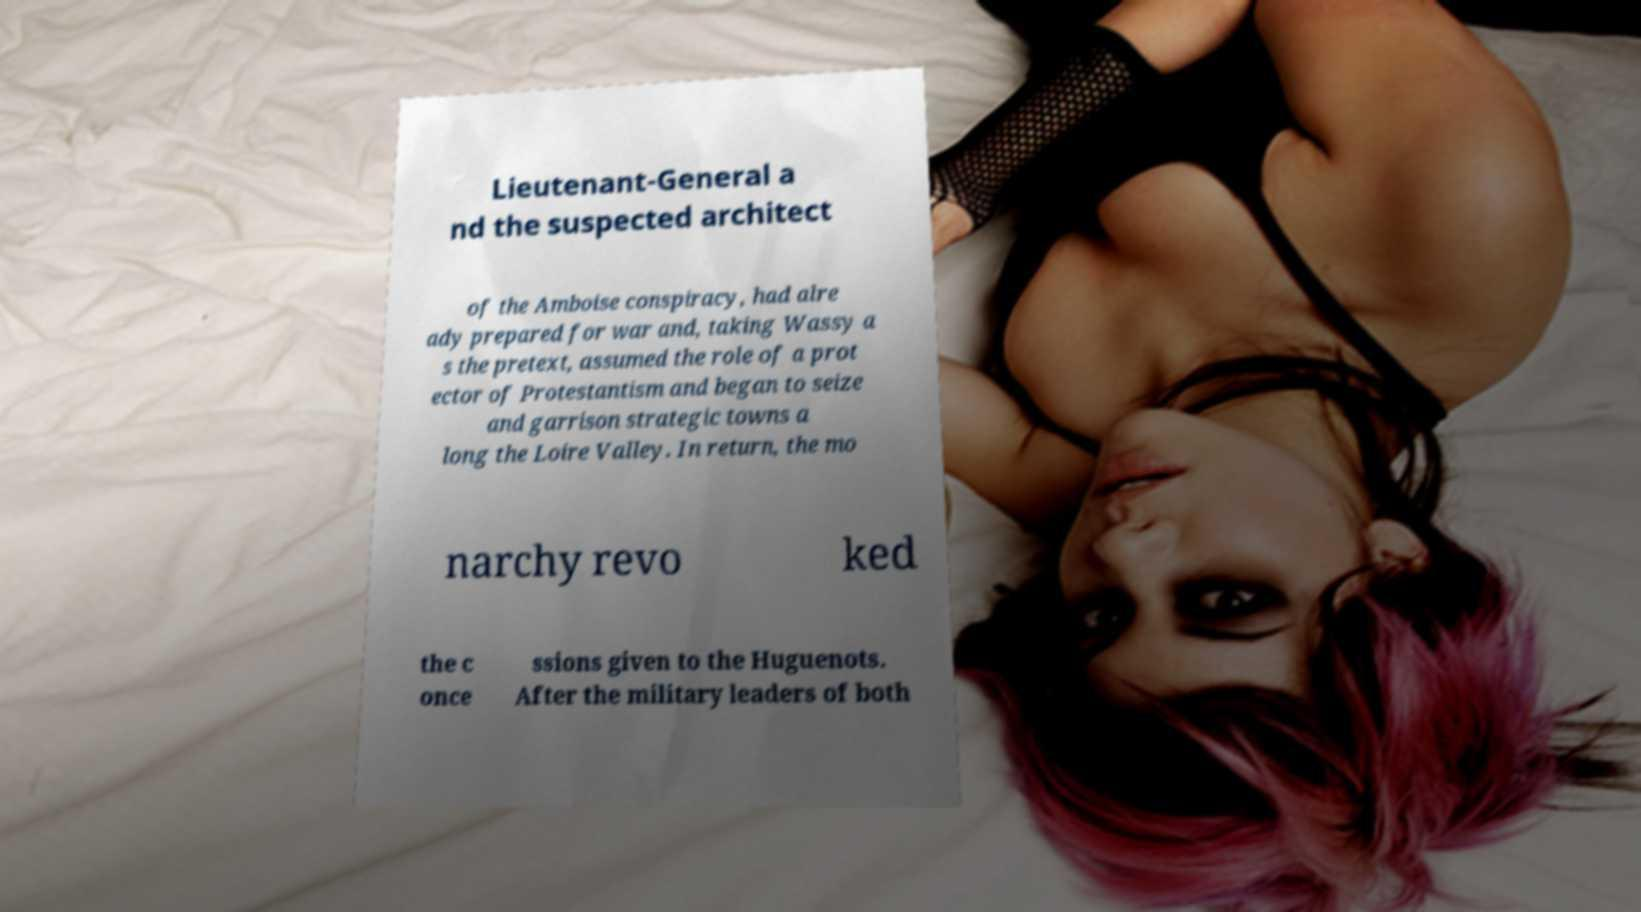What messages or text are displayed in this image? I need them in a readable, typed format. Lieutenant-General a nd the suspected architect of the Amboise conspiracy, had alre ady prepared for war and, taking Wassy a s the pretext, assumed the role of a prot ector of Protestantism and began to seize and garrison strategic towns a long the Loire Valley. In return, the mo narchy revo ked the c once ssions given to the Huguenots. After the military leaders of both 